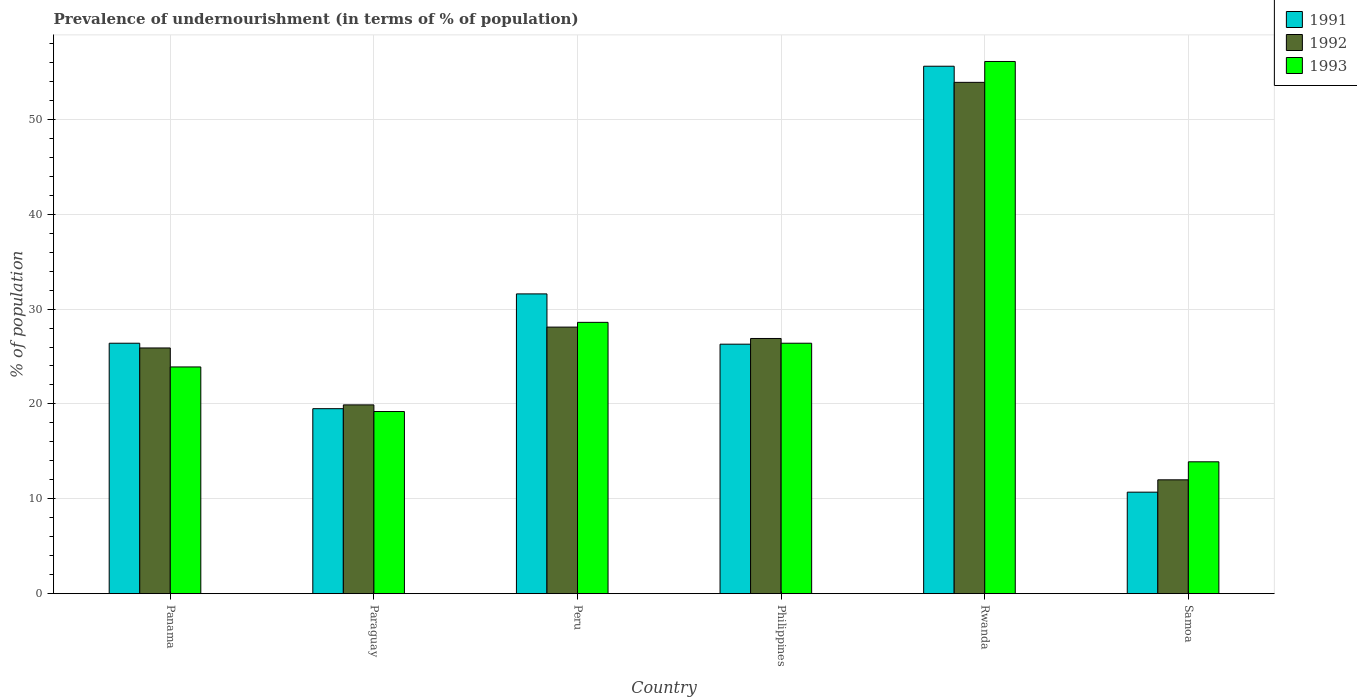How many different coloured bars are there?
Offer a very short reply. 3. Are the number of bars per tick equal to the number of legend labels?
Make the answer very short. Yes. What is the label of the 3rd group of bars from the left?
Provide a succinct answer. Peru. In how many cases, is the number of bars for a given country not equal to the number of legend labels?
Keep it short and to the point. 0. What is the percentage of undernourished population in 1991 in Paraguay?
Offer a very short reply. 19.5. Across all countries, what is the maximum percentage of undernourished population in 1992?
Make the answer very short. 53.9. Across all countries, what is the minimum percentage of undernourished population in 1991?
Offer a very short reply. 10.7. In which country was the percentage of undernourished population in 1992 maximum?
Offer a terse response. Rwanda. In which country was the percentage of undernourished population in 1993 minimum?
Provide a succinct answer. Samoa. What is the total percentage of undernourished population in 1992 in the graph?
Offer a very short reply. 166.7. What is the difference between the percentage of undernourished population in 1991 in Philippines and that in Rwanda?
Offer a very short reply. -29.3. What is the average percentage of undernourished population in 1991 per country?
Keep it short and to the point. 28.35. What is the ratio of the percentage of undernourished population in 1992 in Peru to that in Samoa?
Offer a very short reply. 2.34. Is the percentage of undernourished population in 1992 in Panama less than that in Peru?
Your answer should be compact. Yes. Is the difference between the percentage of undernourished population in 1992 in Peru and Samoa greater than the difference between the percentage of undernourished population in 1993 in Peru and Samoa?
Offer a terse response. Yes. What is the difference between the highest and the second highest percentage of undernourished population in 1991?
Your answer should be compact. -5.2. What is the difference between the highest and the lowest percentage of undernourished population in 1993?
Give a very brief answer. 42.2. In how many countries, is the percentage of undernourished population in 1992 greater than the average percentage of undernourished population in 1992 taken over all countries?
Provide a short and direct response. 2. What does the 1st bar from the left in Philippines represents?
Ensure brevity in your answer.  1991. What does the 2nd bar from the right in Samoa represents?
Ensure brevity in your answer.  1992. Is it the case that in every country, the sum of the percentage of undernourished population in 1991 and percentage of undernourished population in 1993 is greater than the percentage of undernourished population in 1992?
Offer a very short reply. Yes. How many bars are there?
Offer a very short reply. 18. How many countries are there in the graph?
Make the answer very short. 6. What is the difference between two consecutive major ticks on the Y-axis?
Ensure brevity in your answer.  10. Does the graph contain any zero values?
Give a very brief answer. No. How many legend labels are there?
Ensure brevity in your answer.  3. How are the legend labels stacked?
Keep it short and to the point. Vertical. What is the title of the graph?
Provide a succinct answer. Prevalence of undernourishment (in terms of % of population). Does "1979" appear as one of the legend labels in the graph?
Make the answer very short. No. What is the label or title of the X-axis?
Keep it short and to the point. Country. What is the label or title of the Y-axis?
Provide a succinct answer. % of population. What is the % of population in 1991 in Panama?
Your answer should be compact. 26.4. What is the % of population of 1992 in Panama?
Your answer should be very brief. 25.9. What is the % of population of 1993 in Panama?
Offer a terse response. 23.9. What is the % of population of 1993 in Paraguay?
Give a very brief answer. 19.2. What is the % of population of 1991 in Peru?
Your answer should be compact. 31.6. What is the % of population of 1992 in Peru?
Your answer should be compact. 28.1. What is the % of population in 1993 in Peru?
Make the answer very short. 28.6. What is the % of population in 1991 in Philippines?
Offer a very short reply. 26.3. What is the % of population in 1992 in Philippines?
Offer a very short reply. 26.9. What is the % of population in 1993 in Philippines?
Offer a very short reply. 26.4. What is the % of population in 1991 in Rwanda?
Give a very brief answer. 55.6. What is the % of population in 1992 in Rwanda?
Your answer should be compact. 53.9. What is the % of population of 1993 in Rwanda?
Provide a short and direct response. 56.1. What is the % of population in 1992 in Samoa?
Give a very brief answer. 12. What is the % of population in 1993 in Samoa?
Ensure brevity in your answer.  13.9. Across all countries, what is the maximum % of population in 1991?
Provide a short and direct response. 55.6. Across all countries, what is the maximum % of population of 1992?
Give a very brief answer. 53.9. Across all countries, what is the maximum % of population in 1993?
Provide a short and direct response. 56.1. Across all countries, what is the minimum % of population in 1991?
Give a very brief answer. 10.7. Across all countries, what is the minimum % of population of 1992?
Provide a succinct answer. 12. What is the total % of population of 1991 in the graph?
Provide a succinct answer. 170.1. What is the total % of population of 1992 in the graph?
Offer a terse response. 166.7. What is the total % of population of 1993 in the graph?
Your answer should be compact. 168.1. What is the difference between the % of population of 1991 in Panama and that in Paraguay?
Your answer should be compact. 6.9. What is the difference between the % of population in 1993 in Panama and that in Paraguay?
Keep it short and to the point. 4.7. What is the difference between the % of population of 1991 in Panama and that in Peru?
Your response must be concise. -5.2. What is the difference between the % of population of 1993 in Panama and that in Peru?
Ensure brevity in your answer.  -4.7. What is the difference between the % of population in 1992 in Panama and that in Philippines?
Provide a succinct answer. -1. What is the difference between the % of population in 1993 in Panama and that in Philippines?
Your answer should be very brief. -2.5. What is the difference between the % of population in 1991 in Panama and that in Rwanda?
Make the answer very short. -29.2. What is the difference between the % of population of 1992 in Panama and that in Rwanda?
Keep it short and to the point. -28. What is the difference between the % of population in 1993 in Panama and that in Rwanda?
Ensure brevity in your answer.  -32.2. What is the difference between the % of population of 1992 in Panama and that in Samoa?
Offer a very short reply. 13.9. What is the difference between the % of population of 1993 in Panama and that in Samoa?
Your response must be concise. 10. What is the difference between the % of population in 1991 in Paraguay and that in Philippines?
Keep it short and to the point. -6.8. What is the difference between the % of population in 1993 in Paraguay and that in Philippines?
Your answer should be very brief. -7.2. What is the difference between the % of population in 1991 in Paraguay and that in Rwanda?
Your response must be concise. -36.1. What is the difference between the % of population in 1992 in Paraguay and that in Rwanda?
Ensure brevity in your answer.  -34. What is the difference between the % of population in 1993 in Paraguay and that in Rwanda?
Offer a terse response. -36.9. What is the difference between the % of population in 1991 in Peru and that in Philippines?
Your answer should be very brief. 5.3. What is the difference between the % of population of 1992 in Peru and that in Philippines?
Offer a terse response. 1.2. What is the difference between the % of population of 1993 in Peru and that in Philippines?
Offer a very short reply. 2.2. What is the difference between the % of population in 1992 in Peru and that in Rwanda?
Give a very brief answer. -25.8. What is the difference between the % of population in 1993 in Peru and that in Rwanda?
Ensure brevity in your answer.  -27.5. What is the difference between the % of population of 1991 in Peru and that in Samoa?
Your answer should be very brief. 20.9. What is the difference between the % of population in 1993 in Peru and that in Samoa?
Keep it short and to the point. 14.7. What is the difference between the % of population of 1991 in Philippines and that in Rwanda?
Provide a succinct answer. -29.3. What is the difference between the % of population of 1992 in Philippines and that in Rwanda?
Provide a succinct answer. -27. What is the difference between the % of population of 1993 in Philippines and that in Rwanda?
Your answer should be very brief. -29.7. What is the difference between the % of population of 1992 in Philippines and that in Samoa?
Give a very brief answer. 14.9. What is the difference between the % of population of 1993 in Philippines and that in Samoa?
Give a very brief answer. 12.5. What is the difference between the % of population in 1991 in Rwanda and that in Samoa?
Your response must be concise. 44.9. What is the difference between the % of population of 1992 in Rwanda and that in Samoa?
Make the answer very short. 41.9. What is the difference between the % of population in 1993 in Rwanda and that in Samoa?
Your answer should be compact. 42.2. What is the difference between the % of population in 1991 in Panama and the % of population in 1992 in Paraguay?
Your response must be concise. 6.5. What is the difference between the % of population in 1991 in Panama and the % of population in 1993 in Paraguay?
Ensure brevity in your answer.  7.2. What is the difference between the % of population of 1992 in Panama and the % of population of 1993 in Paraguay?
Provide a succinct answer. 6.7. What is the difference between the % of population in 1991 in Panama and the % of population in 1993 in Peru?
Ensure brevity in your answer.  -2.2. What is the difference between the % of population of 1991 in Panama and the % of population of 1993 in Philippines?
Your response must be concise. 0. What is the difference between the % of population of 1991 in Panama and the % of population of 1992 in Rwanda?
Offer a very short reply. -27.5. What is the difference between the % of population of 1991 in Panama and the % of population of 1993 in Rwanda?
Ensure brevity in your answer.  -29.7. What is the difference between the % of population in 1992 in Panama and the % of population in 1993 in Rwanda?
Give a very brief answer. -30.2. What is the difference between the % of population of 1991 in Panama and the % of population of 1992 in Samoa?
Your answer should be compact. 14.4. What is the difference between the % of population of 1992 in Panama and the % of population of 1993 in Samoa?
Your response must be concise. 12. What is the difference between the % of population of 1991 in Paraguay and the % of population of 1992 in Peru?
Keep it short and to the point. -8.6. What is the difference between the % of population of 1991 in Paraguay and the % of population of 1993 in Peru?
Offer a very short reply. -9.1. What is the difference between the % of population in 1991 in Paraguay and the % of population in 1993 in Philippines?
Your response must be concise. -6.9. What is the difference between the % of population of 1992 in Paraguay and the % of population of 1993 in Philippines?
Offer a terse response. -6.5. What is the difference between the % of population in 1991 in Paraguay and the % of population in 1992 in Rwanda?
Keep it short and to the point. -34.4. What is the difference between the % of population in 1991 in Paraguay and the % of population in 1993 in Rwanda?
Give a very brief answer. -36.6. What is the difference between the % of population of 1992 in Paraguay and the % of population of 1993 in Rwanda?
Provide a short and direct response. -36.2. What is the difference between the % of population of 1991 in Paraguay and the % of population of 1992 in Samoa?
Offer a terse response. 7.5. What is the difference between the % of population in 1991 in Peru and the % of population in 1993 in Philippines?
Keep it short and to the point. 5.2. What is the difference between the % of population in 1991 in Peru and the % of population in 1992 in Rwanda?
Ensure brevity in your answer.  -22.3. What is the difference between the % of population of 1991 in Peru and the % of population of 1993 in Rwanda?
Your response must be concise. -24.5. What is the difference between the % of population of 1992 in Peru and the % of population of 1993 in Rwanda?
Offer a very short reply. -28. What is the difference between the % of population of 1991 in Peru and the % of population of 1992 in Samoa?
Offer a very short reply. 19.6. What is the difference between the % of population of 1991 in Peru and the % of population of 1993 in Samoa?
Ensure brevity in your answer.  17.7. What is the difference between the % of population in 1992 in Peru and the % of population in 1993 in Samoa?
Your answer should be compact. 14.2. What is the difference between the % of population of 1991 in Philippines and the % of population of 1992 in Rwanda?
Ensure brevity in your answer.  -27.6. What is the difference between the % of population in 1991 in Philippines and the % of population in 1993 in Rwanda?
Your response must be concise. -29.8. What is the difference between the % of population of 1992 in Philippines and the % of population of 1993 in Rwanda?
Your response must be concise. -29.2. What is the difference between the % of population in 1992 in Philippines and the % of population in 1993 in Samoa?
Ensure brevity in your answer.  13. What is the difference between the % of population in 1991 in Rwanda and the % of population in 1992 in Samoa?
Provide a short and direct response. 43.6. What is the difference between the % of population of 1991 in Rwanda and the % of population of 1993 in Samoa?
Keep it short and to the point. 41.7. What is the difference between the % of population in 1992 in Rwanda and the % of population in 1993 in Samoa?
Offer a terse response. 40. What is the average % of population in 1991 per country?
Make the answer very short. 28.35. What is the average % of population in 1992 per country?
Make the answer very short. 27.78. What is the average % of population of 1993 per country?
Ensure brevity in your answer.  28.02. What is the difference between the % of population of 1991 and % of population of 1993 in Panama?
Provide a succinct answer. 2.5. What is the difference between the % of population in 1992 and % of population in 1993 in Panama?
Provide a succinct answer. 2. What is the difference between the % of population in 1991 and % of population in 1992 in Paraguay?
Provide a succinct answer. -0.4. What is the difference between the % of population in 1991 and % of population in 1992 in Peru?
Keep it short and to the point. 3.5. What is the difference between the % of population in 1991 and % of population in 1993 in Peru?
Provide a short and direct response. 3. What is the difference between the % of population of 1991 and % of population of 1992 in Philippines?
Your answer should be compact. -0.6. What is the difference between the % of population of 1992 and % of population of 1993 in Philippines?
Ensure brevity in your answer.  0.5. What is the difference between the % of population of 1991 and % of population of 1992 in Rwanda?
Offer a terse response. 1.7. What is the difference between the % of population of 1991 and % of population of 1993 in Rwanda?
Your answer should be compact. -0.5. What is the difference between the % of population in 1991 and % of population in 1992 in Samoa?
Keep it short and to the point. -1.3. What is the difference between the % of population in 1992 and % of population in 1993 in Samoa?
Provide a short and direct response. -1.9. What is the ratio of the % of population in 1991 in Panama to that in Paraguay?
Your response must be concise. 1.35. What is the ratio of the % of population of 1992 in Panama to that in Paraguay?
Provide a short and direct response. 1.3. What is the ratio of the % of population in 1993 in Panama to that in Paraguay?
Provide a short and direct response. 1.24. What is the ratio of the % of population in 1991 in Panama to that in Peru?
Your answer should be compact. 0.84. What is the ratio of the % of population in 1992 in Panama to that in Peru?
Provide a short and direct response. 0.92. What is the ratio of the % of population in 1993 in Panama to that in Peru?
Provide a succinct answer. 0.84. What is the ratio of the % of population of 1991 in Panama to that in Philippines?
Your answer should be compact. 1. What is the ratio of the % of population of 1992 in Panama to that in Philippines?
Provide a short and direct response. 0.96. What is the ratio of the % of population in 1993 in Panama to that in Philippines?
Your response must be concise. 0.91. What is the ratio of the % of population in 1991 in Panama to that in Rwanda?
Offer a very short reply. 0.47. What is the ratio of the % of population in 1992 in Panama to that in Rwanda?
Keep it short and to the point. 0.48. What is the ratio of the % of population of 1993 in Panama to that in Rwanda?
Provide a short and direct response. 0.43. What is the ratio of the % of population in 1991 in Panama to that in Samoa?
Ensure brevity in your answer.  2.47. What is the ratio of the % of population of 1992 in Panama to that in Samoa?
Offer a terse response. 2.16. What is the ratio of the % of population of 1993 in Panama to that in Samoa?
Ensure brevity in your answer.  1.72. What is the ratio of the % of population in 1991 in Paraguay to that in Peru?
Your response must be concise. 0.62. What is the ratio of the % of population of 1992 in Paraguay to that in Peru?
Keep it short and to the point. 0.71. What is the ratio of the % of population of 1993 in Paraguay to that in Peru?
Your answer should be compact. 0.67. What is the ratio of the % of population of 1991 in Paraguay to that in Philippines?
Keep it short and to the point. 0.74. What is the ratio of the % of population of 1992 in Paraguay to that in Philippines?
Your answer should be compact. 0.74. What is the ratio of the % of population in 1993 in Paraguay to that in Philippines?
Your response must be concise. 0.73. What is the ratio of the % of population of 1991 in Paraguay to that in Rwanda?
Make the answer very short. 0.35. What is the ratio of the % of population in 1992 in Paraguay to that in Rwanda?
Your answer should be very brief. 0.37. What is the ratio of the % of population of 1993 in Paraguay to that in Rwanda?
Make the answer very short. 0.34. What is the ratio of the % of population in 1991 in Paraguay to that in Samoa?
Your answer should be compact. 1.82. What is the ratio of the % of population of 1992 in Paraguay to that in Samoa?
Offer a terse response. 1.66. What is the ratio of the % of population in 1993 in Paraguay to that in Samoa?
Provide a short and direct response. 1.38. What is the ratio of the % of population in 1991 in Peru to that in Philippines?
Your answer should be compact. 1.2. What is the ratio of the % of population in 1992 in Peru to that in Philippines?
Your answer should be compact. 1.04. What is the ratio of the % of population of 1991 in Peru to that in Rwanda?
Your answer should be compact. 0.57. What is the ratio of the % of population of 1992 in Peru to that in Rwanda?
Your answer should be very brief. 0.52. What is the ratio of the % of population of 1993 in Peru to that in Rwanda?
Ensure brevity in your answer.  0.51. What is the ratio of the % of population in 1991 in Peru to that in Samoa?
Offer a very short reply. 2.95. What is the ratio of the % of population of 1992 in Peru to that in Samoa?
Provide a short and direct response. 2.34. What is the ratio of the % of population of 1993 in Peru to that in Samoa?
Ensure brevity in your answer.  2.06. What is the ratio of the % of population in 1991 in Philippines to that in Rwanda?
Your answer should be very brief. 0.47. What is the ratio of the % of population of 1992 in Philippines to that in Rwanda?
Provide a short and direct response. 0.5. What is the ratio of the % of population of 1993 in Philippines to that in Rwanda?
Your response must be concise. 0.47. What is the ratio of the % of population of 1991 in Philippines to that in Samoa?
Your response must be concise. 2.46. What is the ratio of the % of population in 1992 in Philippines to that in Samoa?
Your response must be concise. 2.24. What is the ratio of the % of population in 1993 in Philippines to that in Samoa?
Give a very brief answer. 1.9. What is the ratio of the % of population of 1991 in Rwanda to that in Samoa?
Ensure brevity in your answer.  5.2. What is the ratio of the % of population of 1992 in Rwanda to that in Samoa?
Offer a terse response. 4.49. What is the ratio of the % of population in 1993 in Rwanda to that in Samoa?
Provide a succinct answer. 4.04. What is the difference between the highest and the second highest % of population of 1991?
Your answer should be very brief. 24. What is the difference between the highest and the second highest % of population in 1992?
Ensure brevity in your answer.  25.8. What is the difference between the highest and the second highest % of population in 1993?
Provide a short and direct response. 27.5. What is the difference between the highest and the lowest % of population of 1991?
Ensure brevity in your answer.  44.9. What is the difference between the highest and the lowest % of population in 1992?
Your response must be concise. 41.9. What is the difference between the highest and the lowest % of population in 1993?
Make the answer very short. 42.2. 